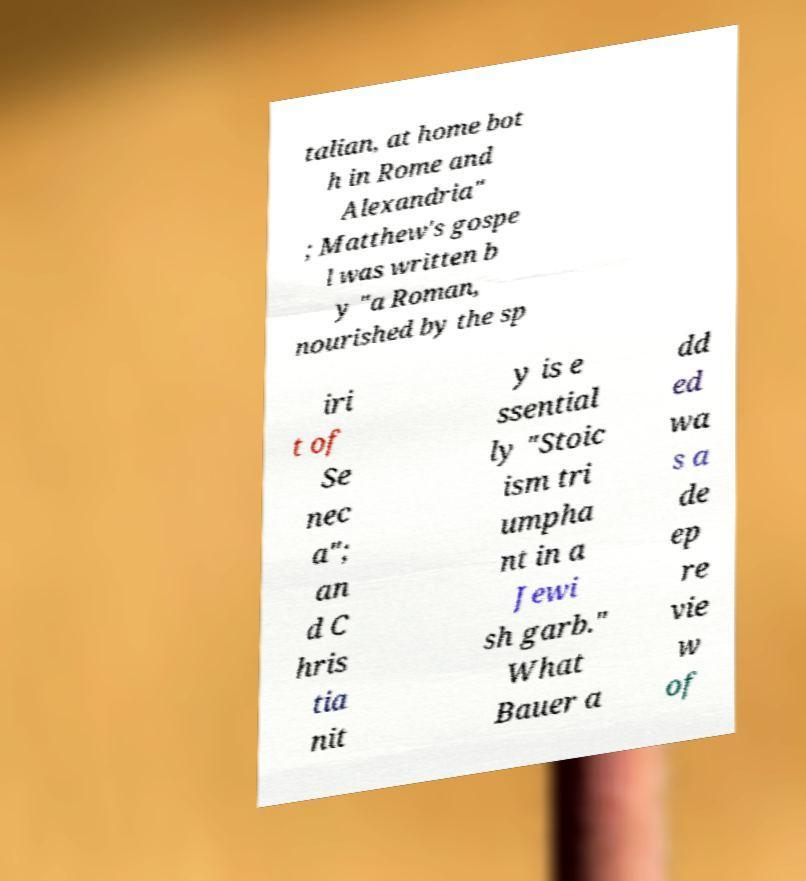Could you extract and type out the text from this image? talian, at home bot h in Rome and Alexandria" ; Matthew's gospe l was written b y "a Roman, nourished by the sp iri t of Se nec a"; an d C hris tia nit y is e ssential ly "Stoic ism tri umpha nt in a Jewi sh garb." What Bauer a dd ed wa s a de ep re vie w of 